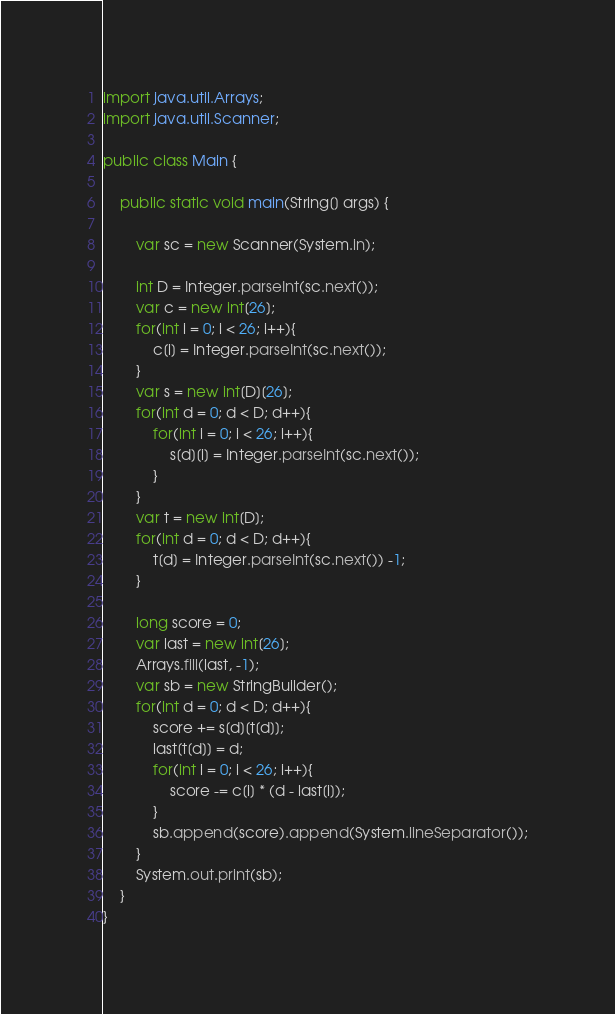<code> <loc_0><loc_0><loc_500><loc_500><_Java_>import java.util.Arrays;
import java.util.Scanner;

public class Main {
    
    public static void main(String[] args) {
        
        var sc = new Scanner(System.in);
    
        int D = Integer.parseInt(sc.next());
        var c = new int[26];
        for(int i = 0; i < 26; i++){
            c[i] = Integer.parseInt(sc.next());
        }
        var s = new int[D][26];
        for(int d = 0; d < D; d++){
            for(int i = 0; i < 26; i++){
                s[d][i] = Integer.parseInt(sc.next());
            }
        }
        var t = new int[D];
        for(int d = 0; d < D; d++){
            t[d] = Integer.parseInt(sc.next()) -1;
        }
        
        long score = 0;
        var last = new int[26];
        Arrays.fill(last, -1);
        var sb = new StringBuilder();
        for(int d = 0; d < D; d++){
            score += s[d][t[d]];
            last[t[d]] = d;
            for(int i = 0; i < 26; i++){
                score -= c[i] * (d - last[i]);
            }
            sb.append(score).append(System.lineSeparator());
        }
        System.out.print(sb);
    }
}</code> 